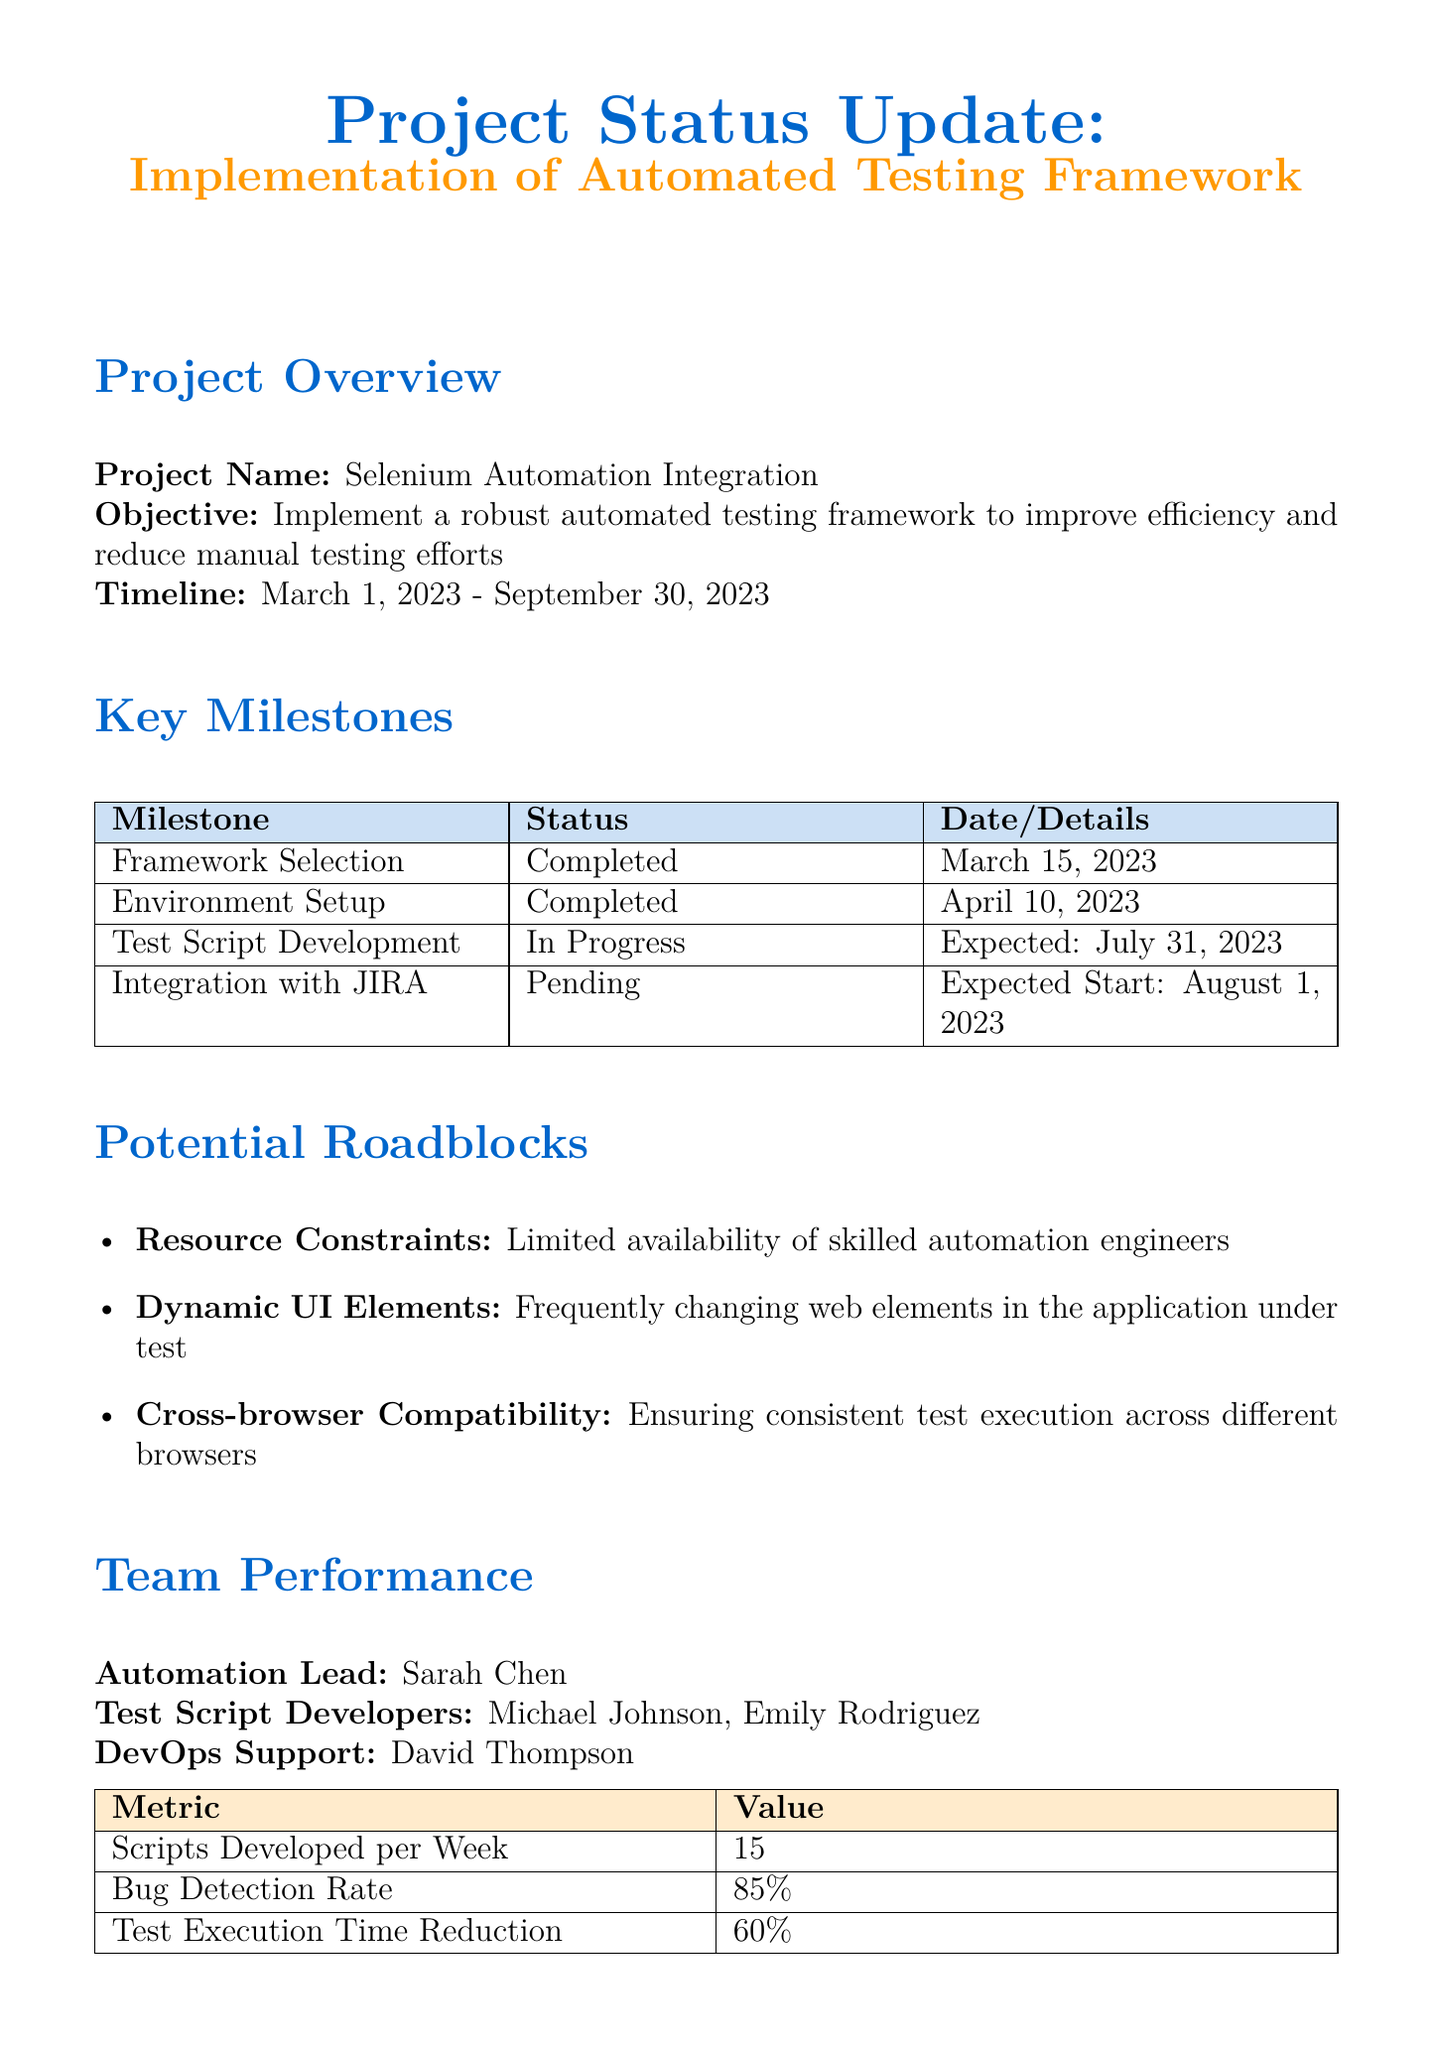what is the project name? The project name is explicitly stated in the document as a part of the project overview section.
Answer: Selenium Automation Integration what is the expected completion date? The expected completion date can be found in the project overview section, which outlines the timeline for the project.
Answer: 2023-09-30 how many test script developers are listed? The document lists the team members involved in the project, which includes the number of test script developers.
Answer: 2 what percentage of test cases have been automated so far? The document states the current progress in automating test cases under the key milestones section for test script development.
Answer: 60% what is the mitigation strategy for resource constraints? The document outlines the impact of resource constraints and presents the mitigation strategy directly in the potential roadblocks section.
Answer: Contracting external resources or providing training what will be the next step after scheduling weekly code review sessions? The next steps are listed in the document, which provides a sequence of actions to take following the initial step mentioned.
Answer: Initiate discussions with the development team what is the bug detection rate achieved by the team? The bug detection rate is mentioned in the team performance section, indicating the effectiveness of the test scripts.
Answer: 85% what tool has been chosen as the primary automation tool? The document specifically highlights the chosen tool for the automation framework in the milestones section.
Answer: Selenium WebDriver 